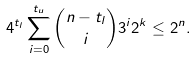Convert formula to latex. <formula><loc_0><loc_0><loc_500><loc_500>4 ^ { t _ { l } } \sum _ { i = 0 } ^ { t _ { u } } \binom { n - { t _ { l } } } { i } 3 ^ { i } 2 ^ { k } \leq 2 ^ { n } .</formula> 